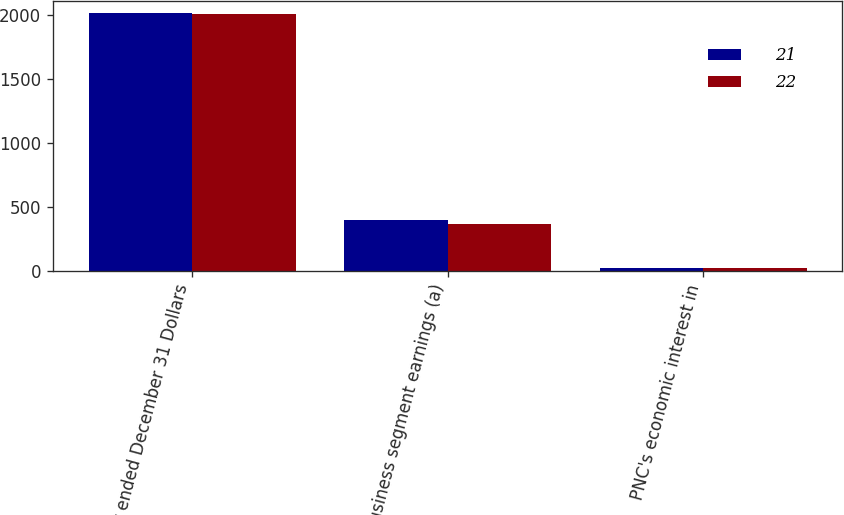<chart> <loc_0><loc_0><loc_500><loc_500><stacked_bar_chart><ecel><fcel>Year ended December 31 Dollars<fcel>Business segment earnings (a)<fcel>PNC's economic interest in<nl><fcel>21<fcel>2012<fcel>395<fcel>22<nl><fcel>22<fcel>2011<fcel>361<fcel>21<nl></chart> 